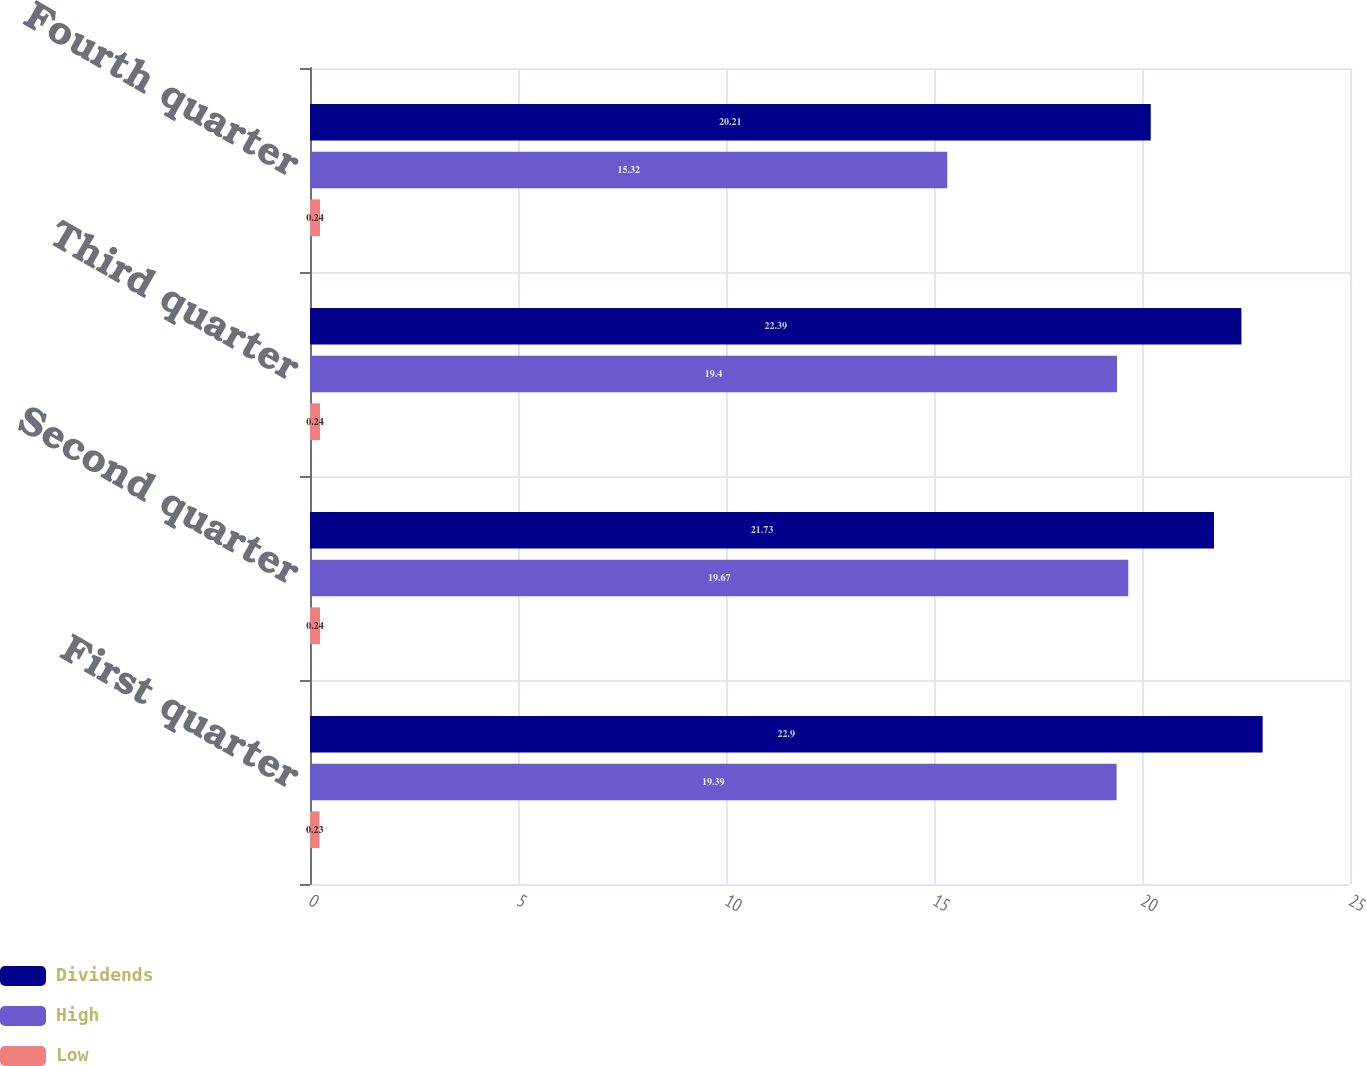Convert chart to OTSL. <chart><loc_0><loc_0><loc_500><loc_500><stacked_bar_chart><ecel><fcel>First quarter<fcel>Second quarter<fcel>Third quarter<fcel>Fourth quarter<nl><fcel>Dividends<fcel>22.9<fcel>21.73<fcel>22.39<fcel>20.21<nl><fcel>High<fcel>19.39<fcel>19.67<fcel>19.4<fcel>15.32<nl><fcel>Low<fcel>0.23<fcel>0.24<fcel>0.24<fcel>0.24<nl></chart> 